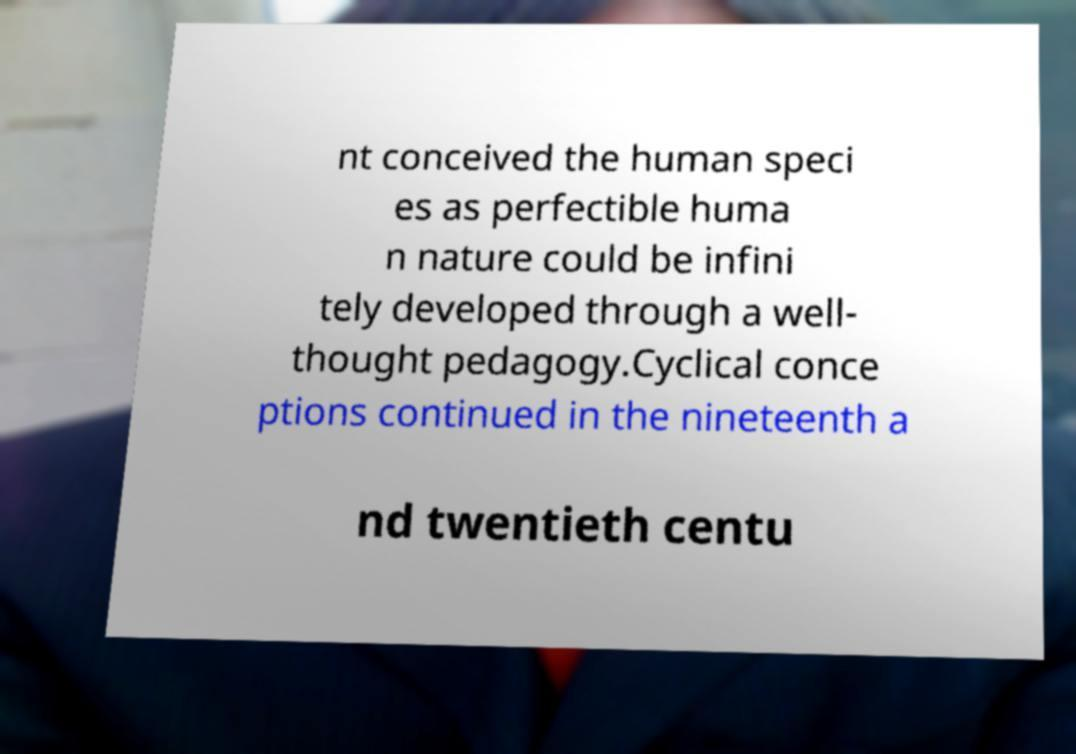For documentation purposes, I need the text within this image transcribed. Could you provide that? nt conceived the human speci es as perfectible huma n nature could be infini tely developed through a well- thought pedagogy.Cyclical conce ptions continued in the nineteenth a nd twentieth centu 